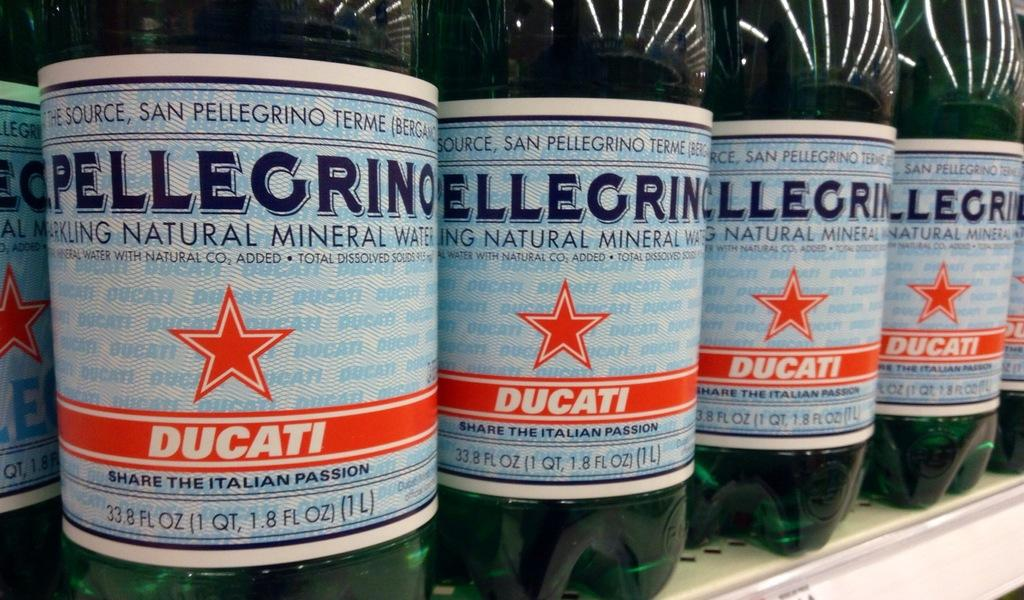<image>
Relay a brief, clear account of the picture shown. Several bottles of Pellegrino Ducati lined up on a shelf. 